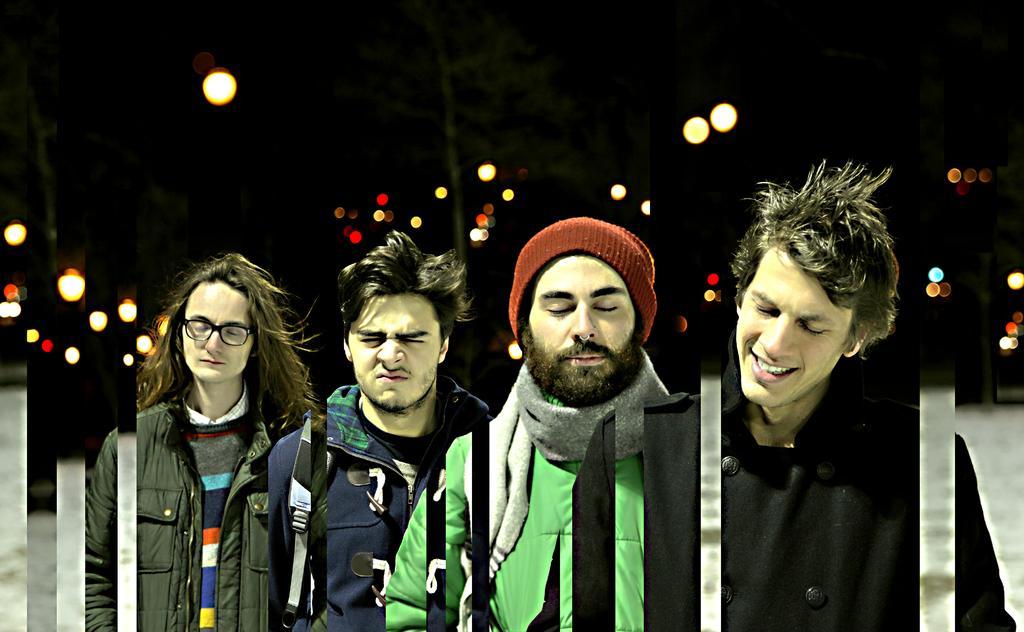Describe this image in one or two sentences. This is an edited image. In this image there are a few people standing and closed their eyes, behind them there are a few lights and trees. The background is dark. 